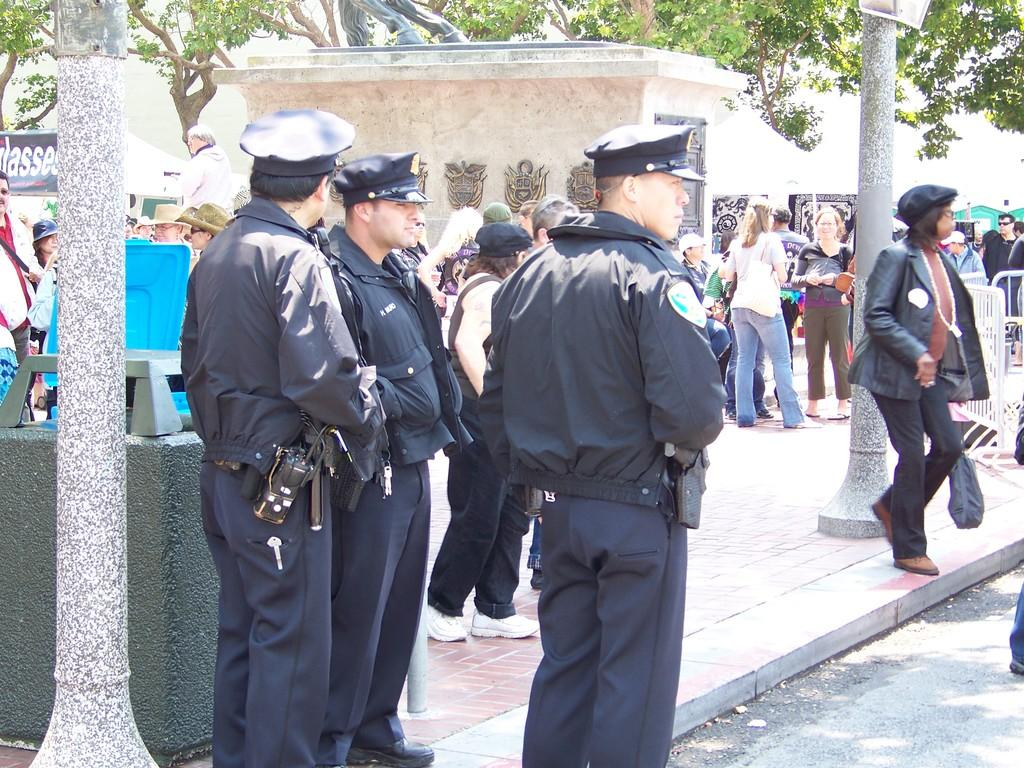What can be seen in the image related to people? There are people standing beside the road in the image. What type of natural elements are present in the image? There are trees around the area in the image. What additional structures or objects can be seen in the image? Banners and tents are visible in the image. What type of seating is available in the scene? There are benches in the scene. What type of dinner is being served in the image? There is no dinner present in the image; it only shows people standing beside the road, trees, banners, tents, and benches. Are there any people sleeping in the image? There is no indication of anyone sleeping in the image; it only shows people standing beside the road. 